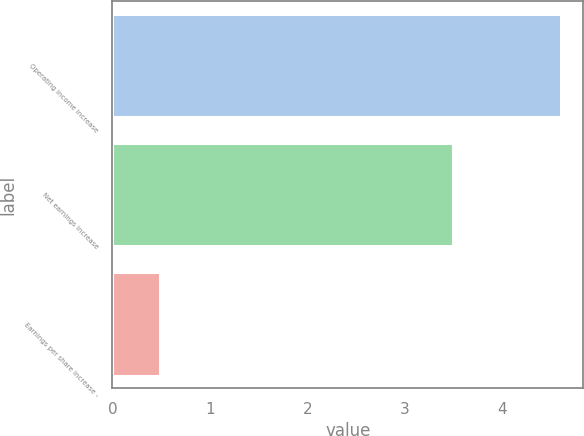<chart> <loc_0><loc_0><loc_500><loc_500><bar_chart><fcel>Operating income increase<fcel>Net earnings increase<fcel>Earnings per share increase -<nl><fcel>4.6<fcel>3.5<fcel>0.49<nl></chart> 